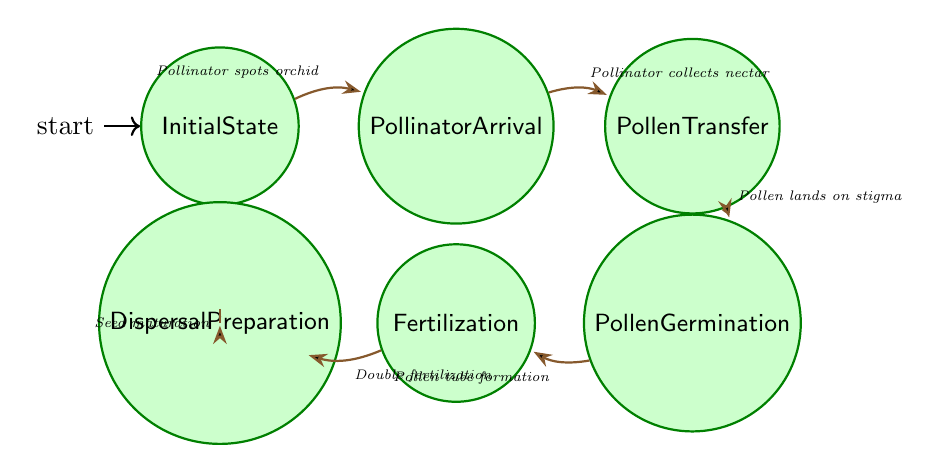What is the starting point of the pollination and fertilization process? The starting point is labeled as "Initial State," which indicates the beginning of the entire sequence of events in the process.
Answer: Initial State How many nodes are depicted in this finite state machine? The diagram features seven distinct states or nodes: Initial State, Pollinator Arrival, Pollen Transfer, Pollen Germination, Fertilization, Seed Formation, and Dispersal Preparation.
Answer: 7 What transition occurs after the Pollinator Arrival state? Following the Pollinator Arrival state, the transition that occurs is when the pollinator collects nectar, leading to the Pollen Transfer state.
Answer: Pollinator collects nectar Which state follows the Fertilization state? The state that follows Fertilization is Seed Formation, which indicates that the fertilization process has led to the development of seeds.
Answer: Seed Formation What is the action needed for pollen transfer to occur? For pollen transfer to occur, pollen grains must land on the stigma, which is a critical step in the pollination process.
Answer: Pollen lands on stigma Describe the transition that occurs after Seed Formation. After Seed Formation, the transition is the maturation of seeds, which prepares the orchid for seed dispersal. This indicates the process of seed development has progressed to readiness for spreading.
Answer: Seed maturation What is the last state in the sequence shown in the diagram? The last state in the sequence is Dispersal Preparation, which signifies the final stage of the pollination and fertilization process in orchids where seeds are prepared for dispersal.
Answer: Dispersal Preparation Identify two consecutive states that involve pollen action. The two consecutive states that involve pollen action are Pollen Transfer and Pollen Germination, marking the stages of pollen being transferred and subsequently germinating.
Answer: Pollen Transfer, Pollen Germination What triggers the transition to Pollinator Arrival? The transition to Pollinator Arrival is triggered when a pollinator spots the orchid, initiating the pollination process.
Answer: Pollinator spots orchid 